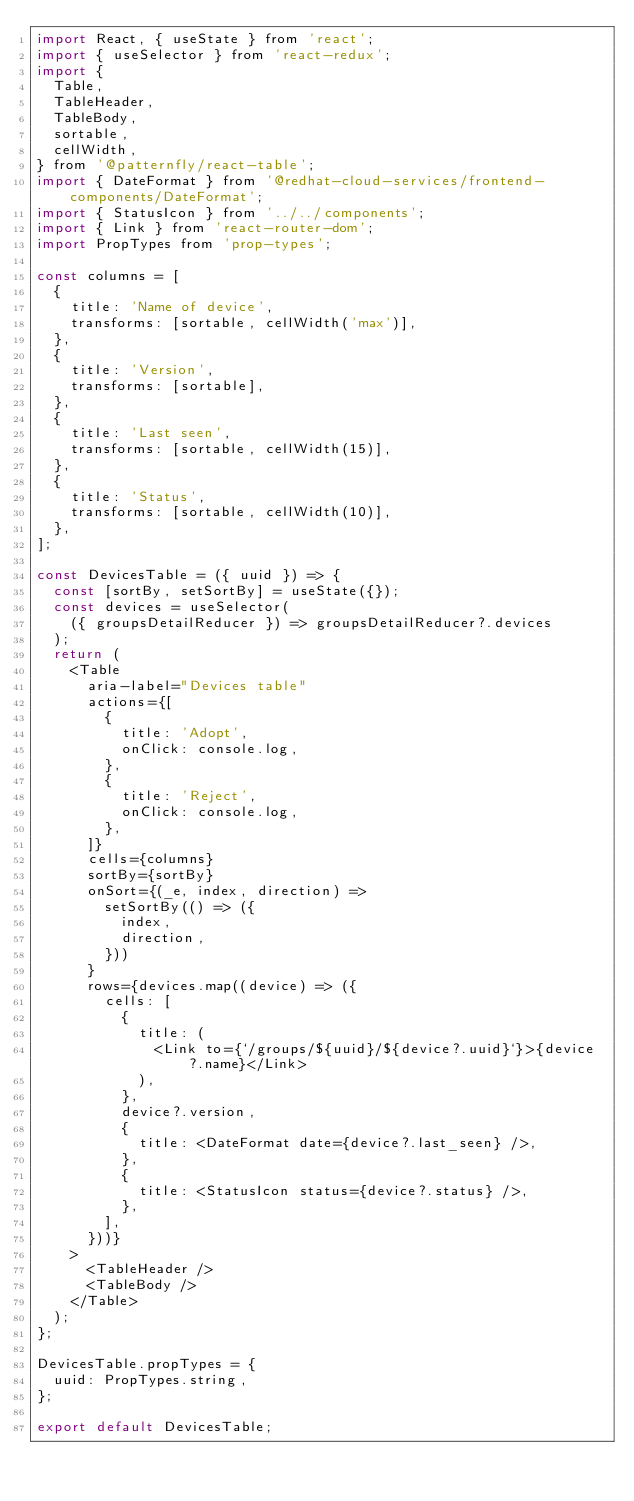<code> <loc_0><loc_0><loc_500><loc_500><_JavaScript_>import React, { useState } from 'react';
import { useSelector } from 'react-redux';
import {
  Table,
  TableHeader,
  TableBody,
  sortable,
  cellWidth,
} from '@patternfly/react-table';
import { DateFormat } from '@redhat-cloud-services/frontend-components/DateFormat';
import { StatusIcon } from '../../components';
import { Link } from 'react-router-dom';
import PropTypes from 'prop-types';

const columns = [
  {
    title: 'Name of device',
    transforms: [sortable, cellWidth('max')],
  },
  {
    title: 'Version',
    transforms: [sortable],
  },
  {
    title: 'Last seen',
    transforms: [sortable, cellWidth(15)],
  },
  {
    title: 'Status',
    transforms: [sortable, cellWidth(10)],
  },
];

const DevicesTable = ({ uuid }) => {
  const [sortBy, setSortBy] = useState({});
  const devices = useSelector(
    ({ groupsDetailReducer }) => groupsDetailReducer?.devices
  );
  return (
    <Table
      aria-label="Devices table"
      actions={[
        {
          title: 'Adopt',
          onClick: console.log,
        },
        {
          title: 'Reject',
          onClick: console.log,
        },
      ]}
      cells={columns}
      sortBy={sortBy}
      onSort={(_e, index, direction) =>
        setSortBy(() => ({
          index,
          direction,
        }))
      }
      rows={devices.map((device) => ({
        cells: [
          {
            title: (
              <Link to={`/groups/${uuid}/${device?.uuid}`}>{device?.name}</Link>
            ),
          },
          device?.version,
          {
            title: <DateFormat date={device?.last_seen} />,
          },
          {
            title: <StatusIcon status={device?.status} />,
          },
        ],
      }))}
    >
      <TableHeader />
      <TableBody />
    </Table>
  );
};

DevicesTable.propTypes = {
  uuid: PropTypes.string,
};

export default DevicesTable;
</code> 